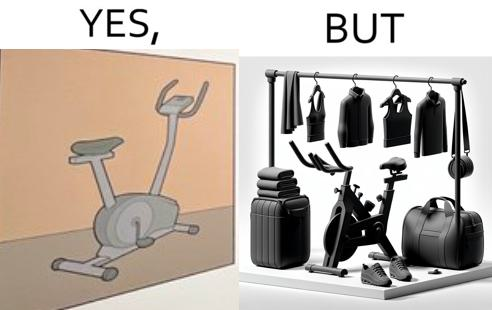Would you classify this image as satirical? Yes, this image is satirical. 